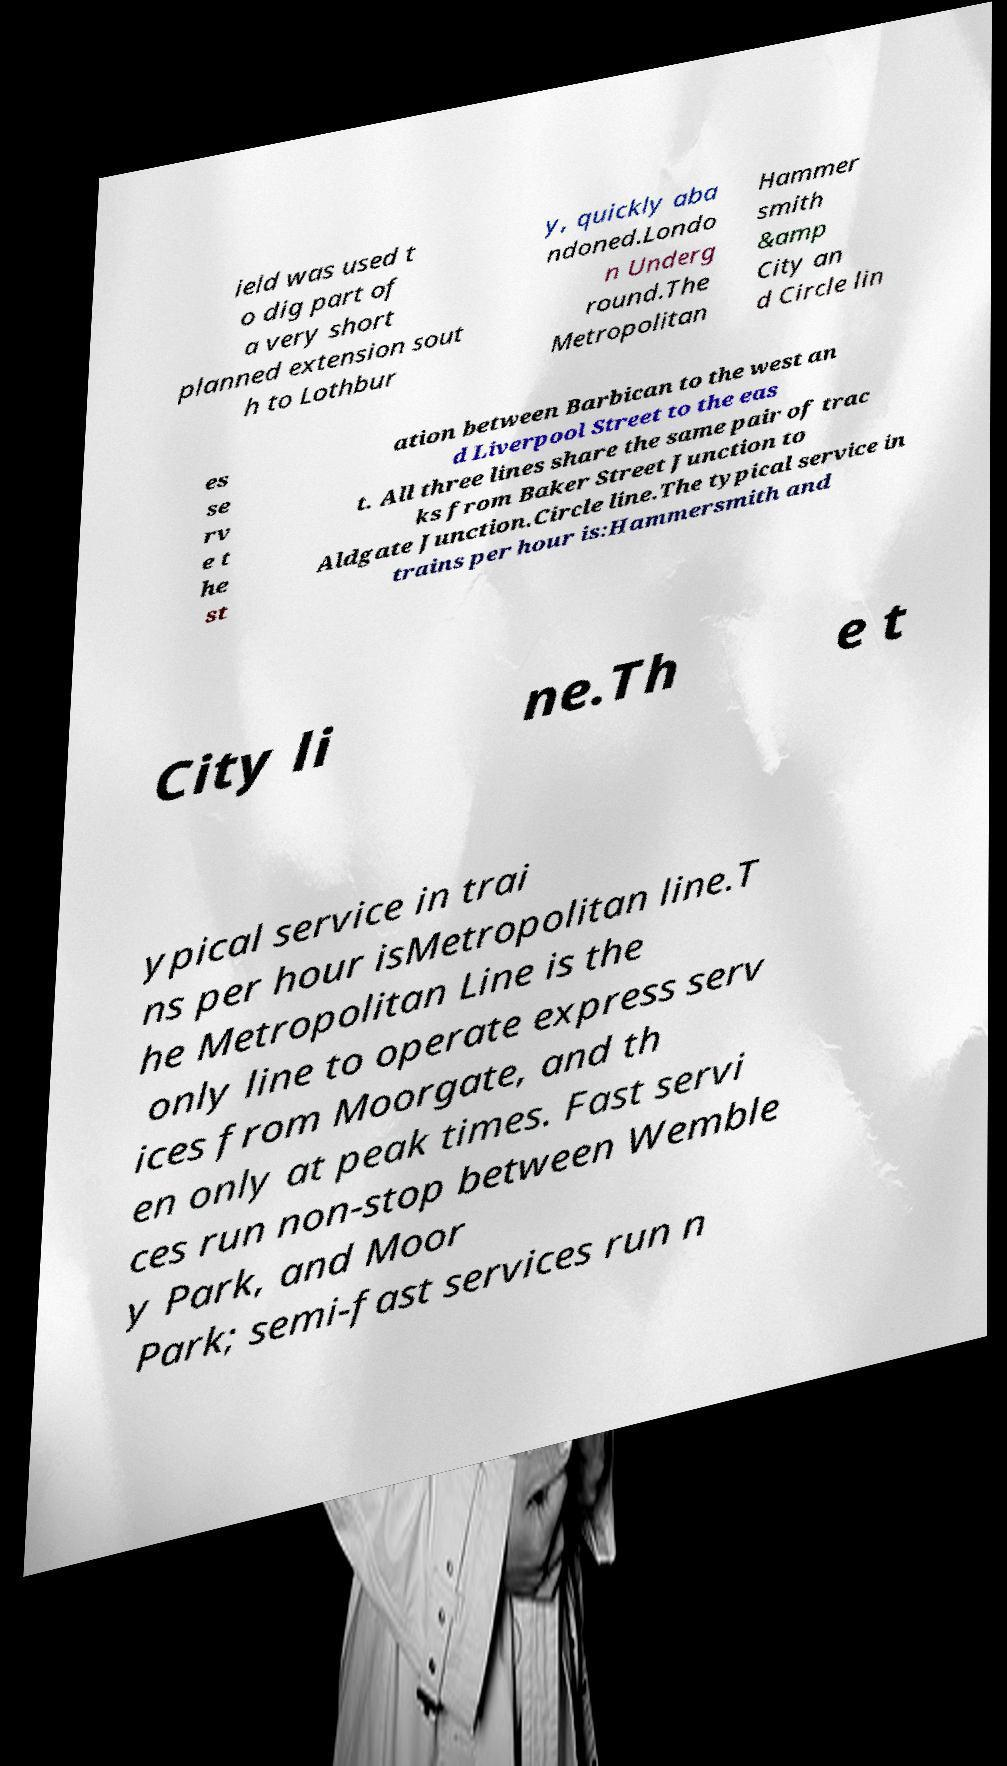What messages or text are displayed in this image? I need them in a readable, typed format. ield was used t o dig part of a very short planned extension sout h to Lothbur y, quickly aba ndoned.Londo n Underg round.The Metropolitan Hammer smith &amp City an d Circle lin es se rv e t he st ation between Barbican to the west an d Liverpool Street to the eas t. All three lines share the same pair of trac ks from Baker Street Junction to Aldgate Junction.Circle line.The typical service in trains per hour is:Hammersmith and City li ne.Th e t ypical service in trai ns per hour isMetropolitan line.T he Metropolitan Line is the only line to operate express serv ices from Moorgate, and th en only at peak times. Fast servi ces run non-stop between Wemble y Park, and Moor Park; semi-fast services run n 